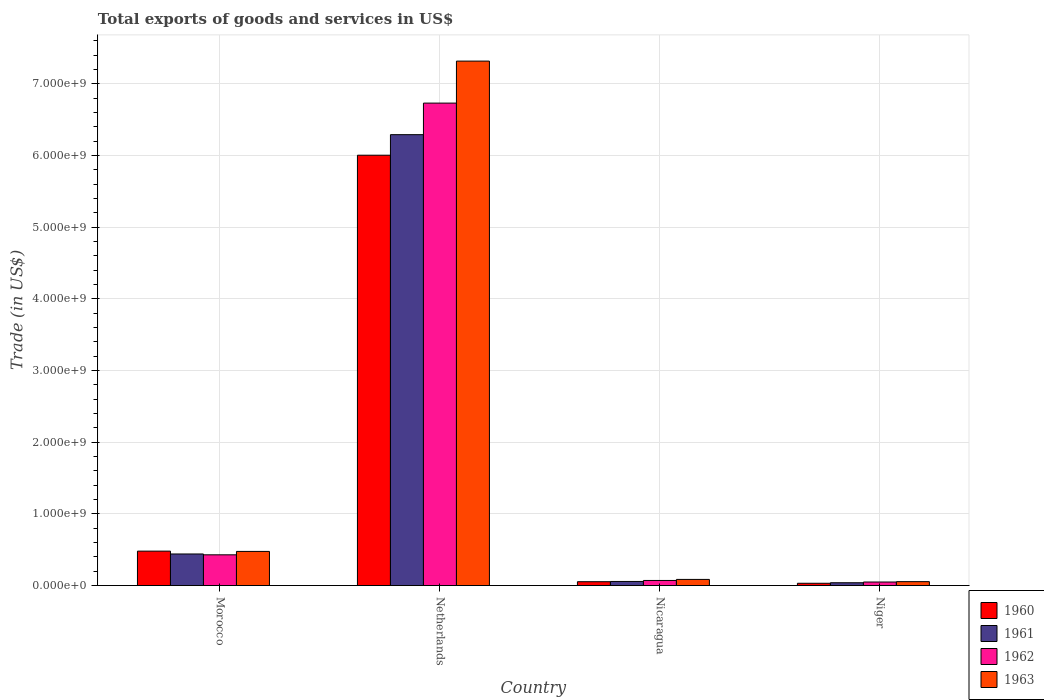How many different coloured bars are there?
Your response must be concise. 4. Are the number of bars per tick equal to the number of legend labels?
Offer a terse response. Yes. Are the number of bars on each tick of the X-axis equal?
Your answer should be very brief. Yes. How many bars are there on the 1st tick from the right?
Offer a very short reply. 4. What is the label of the 1st group of bars from the left?
Provide a short and direct response. Morocco. In how many cases, is the number of bars for a given country not equal to the number of legend labels?
Keep it short and to the point. 0. What is the total exports of goods and services in 1963 in Netherlands?
Provide a short and direct response. 7.32e+09. Across all countries, what is the maximum total exports of goods and services in 1960?
Provide a short and direct response. 6.00e+09. Across all countries, what is the minimum total exports of goods and services in 1963?
Ensure brevity in your answer.  5.46e+07. In which country was the total exports of goods and services in 1960 maximum?
Your response must be concise. Netherlands. In which country was the total exports of goods and services in 1961 minimum?
Ensure brevity in your answer.  Niger. What is the total total exports of goods and services in 1961 in the graph?
Offer a very short reply. 6.83e+09. What is the difference between the total exports of goods and services in 1960 in Netherlands and that in Nicaragua?
Offer a very short reply. 5.95e+09. What is the difference between the total exports of goods and services in 1960 in Morocco and the total exports of goods and services in 1963 in Netherlands?
Your answer should be compact. -6.83e+09. What is the average total exports of goods and services in 1960 per country?
Provide a succinct answer. 1.64e+09. What is the difference between the total exports of goods and services of/in 1961 and total exports of goods and services of/in 1963 in Netherlands?
Offer a terse response. -1.03e+09. In how many countries, is the total exports of goods and services in 1962 greater than 6400000000 US$?
Ensure brevity in your answer.  1. What is the ratio of the total exports of goods and services in 1962 in Netherlands to that in Nicaragua?
Offer a very short reply. 94.54. Is the total exports of goods and services in 1962 in Nicaragua less than that in Niger?
Your answer should be compact. No. Is the difference between the total exports of goods and services in 1961 in Morocco and Nicaragua greater than the difference between the total exports of goods and services in 1963 in Morocco and Nicaragua?
Your answer should be compact. No. What is the difference between the highest and the second highest total exports of goods and services in 1960?
Keep it short and to the point. -4.26e+08. What is the difference between the highest and the lowest total exports of goods and services in 1960?
Offer a terse response. 5.97e+09. What does the 1st bar from the left in Morocco represents?
Provide a short and direct response. 1960. Is it the case that in every country, the sum of the total exports of goods and services in 1961 and total exports of goods and services in 1963 is greater than the total exports of goods and services in 1962?
Your response must be concise. Yes. Are all the bars in the graph horizontal?
Offer a very short reply. No. How many countries are there in the graph?
Give a very brief answer. 4. Does the graph contain any zero values?
Your answer should be compact. No. Where does the legend appear in the graph?
Keep it short and to the point. Bottom right. What is the title of the graph?
Your answer should be compact. Total exports of goods and services in US$. What is the label or title of the Y-axis?
Give a very brief answer. Trade (in US$). What is the Trade (in US$) of 1960 in Morocco?
Offer a very short reply. 4.80e+08. What is the Trade (in US$) of 1961 in Morocco?
Make the answer very short. 4.41e+08. What is the Trade (in US$) of 1962 in Morocco?
Provide a short and direct response. 4.29e+08. What is the Trade (in US$) of 1963 in Morocco?
Your answer should be very brief. 4.76e+08. What is the Trade (in US$) in 1960 in Netherlands?
Your answer should be compact. 6.00e+09. What is the Trade (in US$) in 1961 in Netherlands?
Ensure brevity in your answer.  6.29e+09. What is the Trade (in US$) of 1962 in Netherlands?
Give a very brief answer. 6.73e+09. What is the Trade (in US$) of 1963 in Netherlands?
Ensure brevity in your answer.  7.32e+09. What is the Trade (in US$) in 1960 in Nicaragua?
Make the answer very short. 5.37e+07. What is the Trade (in US$) of 1961 in Nicaragua?
Your answer should be compact. 5.71e+07. What is the Trade (in US$) in 1962 in Nicaragua?
Offer a very short reply. 7.12e+07. What is the Trade (in US$) in 1963 in Nicaragua?
Offer a very short reply. 8.57e+07. What is the Trade (in US$) in 1960 in Niger?
Offer a very short reply. 3.19e+07. What is the Trade (in US$) of 1961 in Niger?
Offer a terse response. 3.95e+07. What is the Trade (in US$) of 1962 in Niger?
Ensure brevity in your answer.  4.94e+07. What is the Trade (in US$) of 1963 in Niger?
Offer a very short reply. 5.46e+07. Across all countries, what is the maximum Trade (in US$) in 1960?
Provide a succinct answer. 6.00e+09. Across all countries, what is the maximum Trade (in US$) of 1961?
Offer a terse response. 6.29e+09. Across all countries, what is the maximum Trade (in US$) in 1962?
Offer a very short reply. 6.73e+09. Across all countries, what is the maximum Trade (in US$) in 1963?
Offer a very short reply. 7.32e+09. Across all countries, what is the minimum Trade (in US$) of 1960?
Provide a short and direct response. 3.19e+07. Across all countries, what is the minimum Trade (in US$) in 1961?
Provide a short and direct response. 3.95e+07. Across all countries, what is the minimum Trade (in US$) in 1962?
Give a very brief answer. 4.94e+07. Across all countries, what is the minimum Trade (in US$) in 1963?
Provide a short and direct response. 5.46e+07. What is the total Trade (in US$) in 1960 in the graph?
Your response must be concise. 6.57e+09. What is the total Trade (in US$) in 1961 in the graph?
Your answer should be compact. 6.83e+09. What is the total Trade (in US$) of 1962 in the graph?
Provide a short and direct response. 7.28e+09. What is the total Trade (in US$) of 1963 in the graph?
Your response must be concise. 7.93e+09. What is the difference between the Trade (in US$) of 1960 in Morocco and that in Netherlands?
Provide a short and direct response. -5.52e+09. What is the difference between the Trade (in US$) in 1961 in Morocco and that in Netherlands?
Keep it short and to the point. -5.85e+09. What is the difference between the Trade (in US$) in 1962 in Morocco and that in Netherlands?
Your response must be concise. -6.30e+09. What is the difference between the Trade (in US$) of 1963 in Morocco and that in Netherlands?
Keep it short and to the point. -6.84e+09. What is the difference between the Trade (in US$) of 1960 in Morocco and that in Nicaragua?
Give a very brief answer. 4.26e+08. What is the difference between the Trade (in US$) of 1961 in Morocco and that in Nicaragua?
Your answer should be compact. 3.84e+08. What is the difference between the Trade (in US$) in 1962 in Morocco and that in Nicaragua?
Your answer should be compact. 3.58e+08. What is the difference between the Trade (in US$) in 1963 in Morocco and that in Nicaragua?
Offer a terse response. 3.91e+08. What is the difference between the Trade (in US$) of 1960 in Morocco and that in Niger?
Your answer should be compact. 4.48e+08. What is the difference between the Trade (in US$) in 1961 in Morocco and that in Niger?
Provide a succinct answer. 4.01e+08. What is the difference between the Trade (in US$) in 1962 in Morocco and that in Niger?
Provide a succinct answer. 3.79e+08. What is the difference between the Trade (in US$) of 1963 in Morocco and that in Niger?
Give a very brief answer. 4.22e+08. What is the difference between the Trade (in US$) of 1960 in Netherlands and that in Nicaragua?
Provide a succinct answer. 5.95e+09. What is the difference between the Trade (in US$) of 1961 in Netherlands and that in Nicaragua?
Keep it short and to the point. 6.23e+09. What is the difference between the Trade (in US$) in 1962 in Netherlands and that in Nicaragua?
Offer a terse response. 6.66e+09. What is the difference between the Trade (in US$) in 1963 in Netherlands and that in Nicaragua?
Keep it short and to the point. 7.23e+09. What is the difference between the Trade (in US$) of 1960 in Netherlands and that in Niger?
Offer a very short reply. 5.97e+09. What is the difference between the Trade (in US$) of 1961 in Netherlands and that in Niger?
Your answer should be very brief. 6.25e+09. What is the difference between the Trade (in US$) of 1962 in Netherlands and that in Niger?
Your answer should be compact. 6.68e+09. What is the difference between the Trade (in US$) of 1963 in Netherlands and that in Niger?
Keep it short and to the point. 7.26e+09. What is the difference between the Trade (in US$) in 1960 in Nicaragua and that in Niger?
Provide a succinct answer. 2.18e+07. What is the difference between the Trade (in US$) in 1961 in Nicaragua and that in Niger?
Your response must be concise. 1.77e+07. What is the difference between the Trade (in US$) of 1962 in Nicaragua and that in Niger?
Your answer should be compact. 2.18e+07. What is the difference between the Trade (in US$) in 1963 in Nicaragua and that in Niger?
Offer a very short reply. 3.11e+07. What is the difference between the Trade (in US$) in 1960 in Morocco and the Trade (in US$) in 1961 in Netherlands?
Provide a short and direct response. -5.81e+09. What is the difference between the Trade (in US$) of 1960 in Morocco and the Trade (in US$) of 1962 in Netherlands?
Provide a short and direct response. -6.25e+09. What is the difference between the Trade (in US$) in 1960 in Morocco and the Trade (in US$) in 1963 in Netherlands?
Ensure brevity in your answer.  -6.83e+09. What is the difference between the Trade (in US$) of 1961 in Morocco and the Trade (in US$) of 1962 in Netherlands?
Provide a short and direct response. -6.29e+09. What is the difference between the Trade (in US$) of 1961 in Morocco and the Trade (in US$) of 1963 in Netherlands?
Give a very brief answer. -6.87e+09. What is the difference between the Trade (in US$) of 1962 in Morocco and the Trade (in US$) of 1963 in Netherlands?
Offer a terse response. -6.89e+09. What is the difference between the Trade (in US$) in 1960 in Morocco and the Trade (in US$) in 1961 in Nicaragua?
Offer a very short reply. 4.23e+08. What is the difference between the Trade (in US$) in 1960 in Morocco and the Trade (in US$) in 1962 in Nicaragua?
Your answer should be compact. 4.09e+08. What is the difference between the Trade (in US$) in 1960 in Morocco and the Trade (in US$) in 1963 in Nicaragua?
Your answer should be compact. 3.94e+08. What is the difference between the Trade (in US$) in 1961 in Morocco and the Trade (in US$) in 1962 in Nicaragua?
Give a very brief answer. 3.69e+08. What is the difference between the Trade (in US$) of 1961 in Morocco and the Trade (in US$) of 1963 in Nicaragua?
Your answer should be compact. 3.55e+08. What is the difference between the Trade (in US$) in 1962 in Morocco and the Trade (in US$) in 1963 in Nicaragua?
Give a very brief answer. 3.43e+08. What is the difference between the Trade (in US$) of 1960 in Morocco and the Trade (in US$) of 1961 in Niger?
Your answer should be compact. 4.41e+08. What is the difference between the Trade (in US$) in 1960 in Morocco and the Trade (in US$) in 1962 in Niger?
Your answer should be compact. 4.31e+08. What is the difference between the Trade (in US$) in 1960 in Morocco and the Trade (in US$) in 1963 in Niger?
Provide a short and direct response. 4.26e+08. What is the difference between the Trade (in US$) in 1961 in Morocco and the Trade (in US$) in 1962 in Niger?
Your answer should be compact. 3.91e+08. What is the difference between the Trade (in US$) of 1961 in Morocco and the Trade (in US$) of 1963 in Niger?
Offer a very short reply. 3.86e+08. What is the difference between the Trade (in US$) of 1962 in Morocco and the Trade (in US$) of 1963 in Niger?
Your answer should be compact. 3.74e+08. What is the difference between the Trade (in US$) of 1960 in Netherlands and the Trade (in US$) of 1961 in Nicaragua?
Your response must be concise. 5.95e+09. What is the difference between the Trade (in US$) of 1960 in Netherlands and the Trade (in US$) of 1962 in Nicaragua?
Offer a terse response. 5.93e+09. What is the difference between the Trade (in US$) in 1960 in Netherlands and the Trade (in US$) in 1963 in Nicaragua?
Your answer should be compact. 5.92e+09. What is the difference between the Trade (in US$) in 1961 in Netherlands and the Trade (in US$) in 1962 in Nicaragua?
Your answer should be very brief. 6.22e+09. What is the difference between the Trade (in US$) in 1961 in Netherlands and the Trade (in US$) in 1963 in Nicaragua?
Keep it short and to the point. 6.20e+09. What is the difference between the Trade (in US$) of 1962 in Netherlands and the Trade (in US$) of 1963 in Nicaragua?
Make the answer very short. 6.64e+09. What is the difference between the Trade (in US$) in 1960 in Netherlands and the Trade (in US$) in 1961 in Niger?
Provide a short and direct response. 5.96e+09. What is the difference between the Trade (in US$) in 1960 in Netherlands and the Trade (in US$) in 1962 in Niger?
Ensure brevity in your answer.  5.95e+09. What is the difference between the Trade (in US$) in 1960 in Netherlands and the Trade (in US$) in 1963 in Niger?
Provide a succinct answer. 5.95e+09. What is the difference between the Trade (in US$) in 1961 in Netherlands and the Trade (in US$) in 1962 in Niger?
Your answer should be very brief. 6.24e+09. What is the difference between the Trade (in US$) in 1961 in Netherlands and the Trade (in US$) in 1963 in Niger?
Your answer should be compact. 6.23e+09. What is the difference between the Trade (in US$) in 1962 in Netherlands and the Trade (in US$) in 1963 in Niger?
Keep it short and to the point. 6.67e+09. What is the difference between the Trade (in US$) in 1960 in Nicaragua and the Trade (in US$) in 1961 in Niger?
Provide a succinct answer. 1.43e+07. What is the difference between the Trade (in US$) in 1960 in Nicaragua and the Trade (in US$) in 1962 in Niger?
Offer a terse response. 4.38e+06. What is the difference between the Trade (in US$) of 1960 in Nicaragua and the Trade (in US$) of 1963 in Niger?
Offer a terse response. -8.46e+05. What is the difference between the Trade (in US$) in 1961 in Nicaragua and the Trade (in US$) in 1962 in Niger?
Offer a terse response. 7.77e+06. What is the difference between the Trade (in US$) of 1961 in Nicaragua and the Trade (in US$) of 1963 in Niger?
Your answer should be compact. 2.54e+06. What is the difference between the Trade (in US$) in 1962 in Nicaragua and the Trade (in US$) in 1963 in Niger?
Keep it short and to the point. 1.66e+07. What is the average Trade (in US$) in 1960 per country?
Offer a terse response. 1.64e+09. What is the average Trade (in US$) of 1961 per country?
Your answer should be compact. 1.71e+09. What is the average Trade (in US$) of 1962 per country?
Offer a terse response. 1.82e+09. What is the average Trade (in US$) of 1963 per country?
Make the answer very short. 1.98e+09. What is the difference between the Trade (in US$) in 1960 and Trade (in US$) in 1961 in Morocco?
Provide a succinct answer. 3.95e+07. What is the difference between the Trade (in US$) of 1960 and Trade (in US$) of 1962 in Morocco?
Make the answer very short. 5.14e+07. What is the difference between the Trade (in US$) of 1960 and Trade (in US$) of 1963 in Morocco?
Offer a very short reply. 3.95e+06. What is the difference between the Trade (in US$) in 1961 and Trade (in US$) in 1962 in Morocco?
Give a very brief answer. 1.19e+07. What is the difference between the Trade (in US$) of 1961 and Trade (in US$) of 1963 in Morocco?
Give a very brief answer. -3.56e+07. What is the difference between the Trade (in US$) of 1962 and Trade (in US$) of 1963 in Morocco?
Offer a terse response. -4.74e+07. What is the difference between the Trade (in US$) of 1960 and Trade (in US$) of 1961 in Netherlands?
Your answer should be very brief. -2.87e+08. What is the difference between the Trade (in US$) in 1960 and Trade (in US$) in 1962 in Netherlands?
Your answer should be very brief. -7.27e+08. What is the difference between the Trade (in US$) in 1960 and Trade (in US$) in 1963 in Netherlands?
Your answer should be very brief. -1.31e+09. What is the difference between the Trade (in US$) in 1961 and Trade (in US$) in 1962 in Netherlands?
Make the answer very short. -4.40e+08. What is the difference between the Trade (in US$) in 1961 and Trade (in US$) in 1963 in Netherlands?
Your response must be concise. -1.03e+09. What is the difference between the Trade (in US$) in 1962 and Trade (in US$) in 1963 in Netherlands?
Your answer should be very brief. -5.86e+08. What is the difference between the Trade (in US$) of 1960 and Trade (in US$) of 1961 in Nicaragua?
Make the answer very short. -3.39e+06. What is the difference between the Trade (in US$) in 1960 and Trade (in US$) in 1962 in Nicaragua?
Your response must be concise. -1.74e+07. What is the difference between the Trade (in US$) in 1960 and Trade (in US$) in 1963 in Nicaragua?
Make the answer very short. -3.20e+07. What is the difference between the Trade (in US$) of 1961 and Trade (in US$) of 1962 in Nicaragua?
Give a very brief answer. -1.40e+07. What is the difference between the Trade (in US$) of 1961 and Trade (in US$) of 1963 in Nicaragua?
Provide a succinct answer. -2.86e+07. What is the difference between the Trade (in US$) in 1962 and Trade (in US$) in 1963 in Nicaragua?
Give a very brief answer. -1.45e+07. What is the difference between the Trade (in US$) of 1960 and Trade (in US$) of 1961 in Niger?
Ensure brevity in your answer.  -7.53e+06. What is the difference between the Trade (in US$) in 1960 and Trade (in US$) in 1962 in Niger?
Your answer should be very brief. -1.74e+07. What is the difference between the Trade (in US$) of 1960 and Trade (in US$) of 1963 in Niger?
Keep it short and to the point. -2.27e+07. What is the difference between the Trade (in US$) of 1961 and Trade (in US$) of 1962 in Niger?
Your answer should be very brief. -9.91e+06. What is the difference between the Trade (in US$) in 1961 and Trade (in US$) in 1963 in Niger?
Offer a very short reply. -1.51e+07. What is the difference between the Trade (in US$) in 1962 and Trade (in US$) in 1963 in Niger?
Your response must be concise. -5.23e+06. What is the ratio of the Trade (in US$) of 1961 in Morocco to that in Netherlands?
Your answer should be very brief. 0.07. What is the ratio of the Trade (in US$) of 1962 in Morocco to that in Netherlands?
Your answer should be very brief. 0.06. What is the ratio of the Trade (in US$) in 1963 in Morocco to that in Netherlands?
Your response must be concise. 0.07. What is the ratio of the Trade (in US$) in 1960 in Morocco to that in Nicaragua?
Provide a short and direct response. 8.93. What is the ratio of the Trade (in US$) in 1961 in Morocco to that in Nicaragua?
Make the answer very short. 7.71. What is the ratio of the Trade (in US$) in 1962 in Morocco to that in Nicaragua?
Provide a short and direct response. 6.02. What is the ratio of the Trade (in US$) of 1963 in Morocco to that in Nicaragua?
Offer a very short reply. 5.56. What is the ratio of the Trade (in US$) of 1960 in Morocco to that in Niger?
Give a very brief answer. 15.04. What is the ratio of the Trade (in US$) in 1961 in Morocco to that in Niger?
Give a very brief answer. 11.17. What is the ratio of the Trade (in US$) in 1962 in Morocco to that in Niger?
Provide a succinct answer. 8.69. What is the ratio of the Trade (in US$) in 1963 in Morocco to that in Niger?
Offer a very short reply. 8.72. What is the ratio of the Trade (in US$) in 1960 in Netherlands to that in Nicaragua?
Provide a succinct answer. 111.69. What is the ratio of the Trade (in US$) of 1961 in Netherlands to that in Nicaragua?
Provide a succinct answer. 110.08. What is the ratio of the Trade (in US$) in 1962 in Netherlands to that in Nicaragua?
Give a very brief answer. 94.54. What is the ratio of the Trade (in US$) of 1963 in Netherlands to that in Nicaragua?
Provide a short and direct response. 85.36. What is the ratio of the Trade (in US$) of 1960 in Netherlands to that in Niger?
Offer a very short reply. 188.06. What is the ratio of the Trade (in US$) in 1961 in Netherlands to that in Niger?
Make the answer very short. 159.41. What is the ratio of the Trade (in US$) in 1962 in Netherlands to that in Niger?
Ensure brevity in your answer.  136.32. What is the ratio of the Trade (in US$) in 1963 in Netherlands to that in Niger?
Give a very brief answer. 134. What is the ratio of the Trade (in US$) of 1960 in Nicaragua to that in Niger?
Offer a very short reply. 1.68. What is the ratio of the Trade (in US$) of 1961 in Nicaragua to that in Niger?
Keep it short and to the point. 1.45. What is the ratio of the Trade (in US$) in 1962 in Nicaragua to that in Niger?
Give a very brief answer. 1.44. What is the ratio of the Trade (in US$) in 1963 in Nicaragua to that in Niger?
Keep it short and to the point. 1.57. What is the difference between the highest and the second highest Trade (in US$) in 1960?
Offer a terse response. 5.52e+09. What is the difference between the highest and the second highest Trade (in US$) of 1961?
Your answer should be compact. 5.85e+09. What is the difference between the highest and the second highest Trade (in US$) of 1962?
Provide a short and direct response. 6.30e+09. What is the difference between the highest and the second highest Trade (in US$) of 1963?
Your answer should be compact. 6.84e+09. What is the difference between the highest and the lowest Trade (in US$) of 1960?
Provide a short and direct response. 5.97e+09. What is the difference between the highest and the lowest Trade (in US$) in 1961?
Make the answer very short. 6.25e+09. What is the difference between the highest and the lowest Trade (in US$) of 1962?
Your answer should be very brief. 6.68e+09. What is the difference between the highest and the lowest Trade (in US$) in 1963?
Offer a terse response. 7.26e+09. 